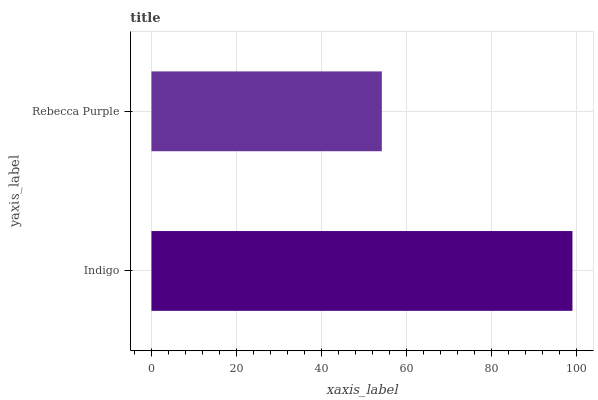Is Rebecca Purple the minimum?
Answer yes or no. Yes. Is Indigo the maximum?
Answer yes or no. Yes. Is Rebecca Purple the maximum?
Answer yes or no. No. Is Indigo greater than Rebecca Purple?
Answer yes or no. Yes. Is Rebecca Purple less than Indigo?
Answer yes or no. Yes. Is Rebecca Purple greater than Indigo?
Answer yes or no. No. Is Indigo less than Rebecca Purple?
Answer yes or no. No. Is Indigo the high median?
Answer yes or no. Yes. Is Rebecca Purple the low median?
Answer yes or no. Yes. Is Rebecca Purple the high median?
Answer yes or no. No. Is Indigo the low median?
Answer yes or no. No. 